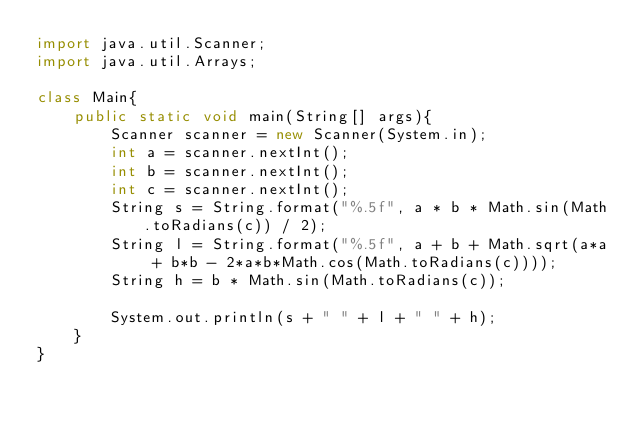Convert code to text. <code><loc_0><loc_0><loc_500><loc_500><_Java_>import java.util.Scanner;
import java.util.Arrays;

class Main{
	public static void main(String[] args){
		Scanner scanner = new Scanner(System.in);
		int a = scanner.nextInt();
		int b = scanner.nextInt();
		int c = scanner.nextInt();
		String s = String.format("%.5f", a * b * Math.sin(Math.toRadians(c)) / 2);
		String l = String.format("%.5f", a + b + Math.sqrt(a*a + b*b - 2*a*b*Math.cos(Math.toRadians(c))));
		String h = b * Math.sin(Math.toRadians(c));
		
		System.out.println(s + " " + l + " " + h);
	}
}</code> 